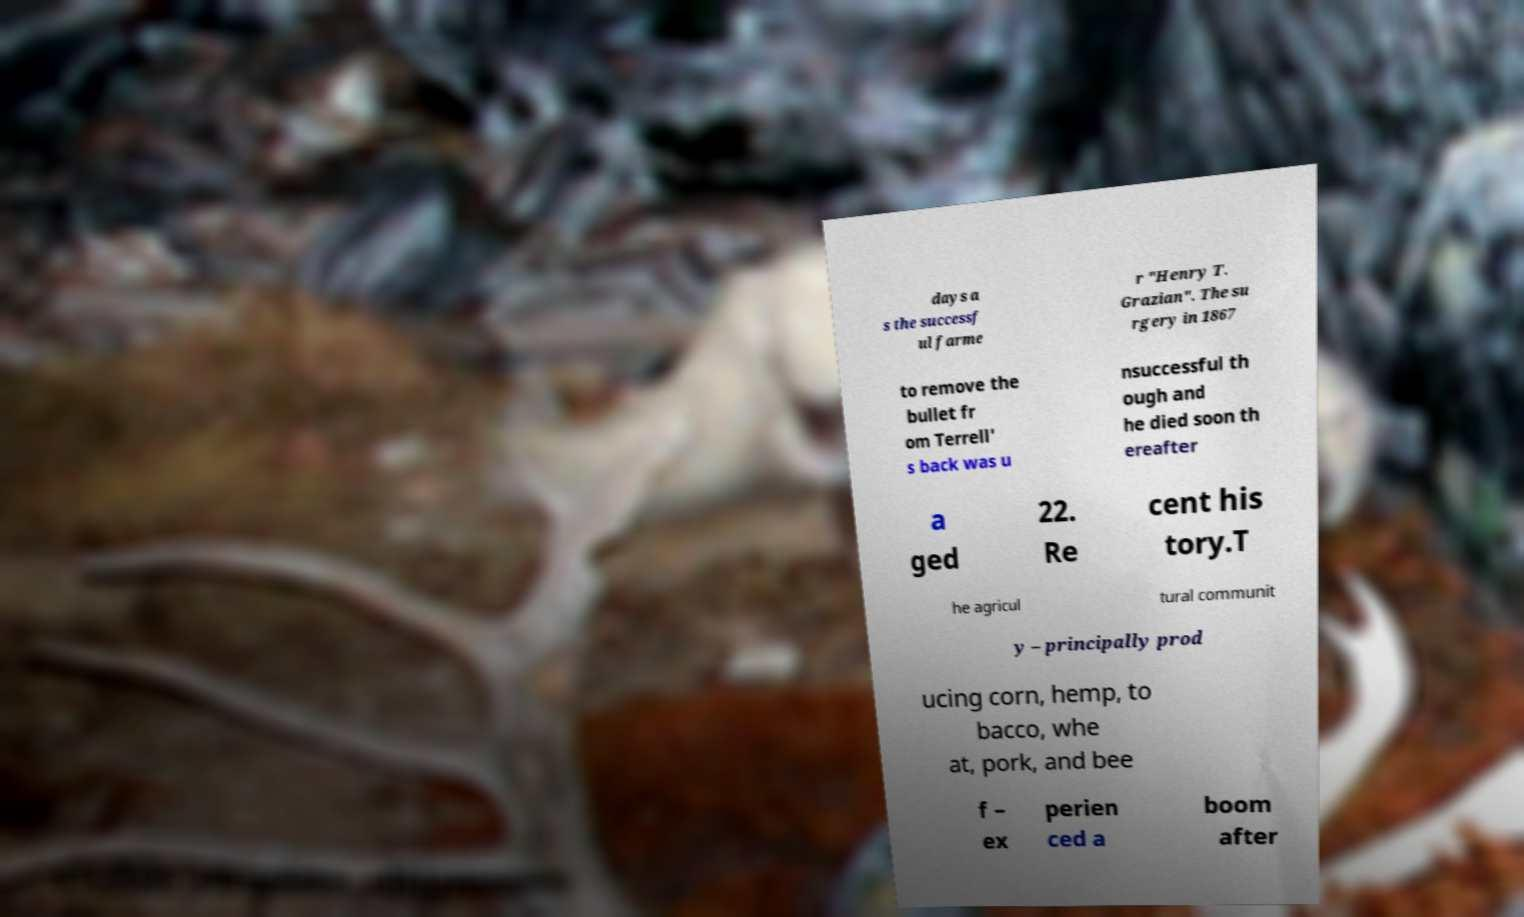Can you accurately transcribe the text from the provided image for me? days a s the successf ul farme r "Henry T. Grazian". The su rgery in 1867 to remove the bullet fr om Terrell' s back was u nsuccessful th ough and he died soon th ereafter a ged 22. Re cent his tory.T he agricul tural communit y – principally prod ucing corn, hemp, to bacco, whe at, pork, and bee f – ex perien ced a boom after 